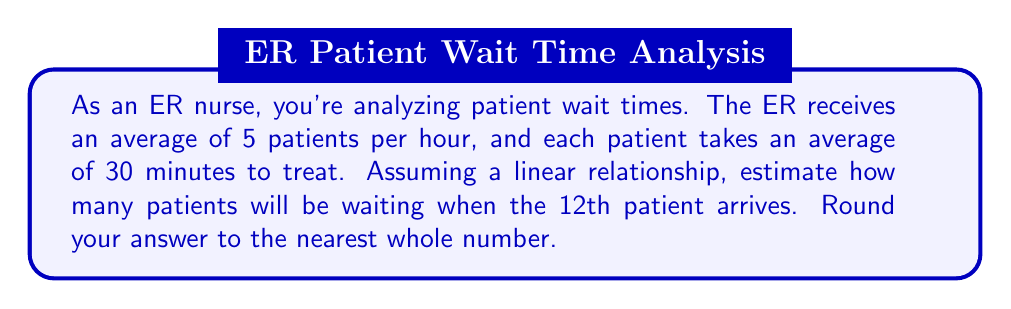Can you answer this question? Let's approach this step-by-step:

1) First, we need to determine how long it takes for the 12th patient to arrive:
   $$ \text{Time for 12th patient} = \frac{12 \text{ patients}}{5 \text{ patients/hour}} = 2.4 \text{ hours} $$

2) In 2.4 hours, the number of patients that can be treated is:
   $$ \text{Patients treated} = \frac{2.4 \text{ hours}}{0.5 \text{ hours/patient}} = 4.8 \text{ patients} $$

3) The number of waiting patients is the difference between arrivals and treatments:
   $$ \text{Waiting patients} = \text{Arrivals} - \text{Treated} $$
   $$ \text{Waiting patients} = 12 - 4.8 = 7.2 $$

4) Rounding to the nearest whole number:
   $$ \text{Waiting patients} \approx 7 $$

This linear model assumes constant arrival and treatment rates, which is a simplification of real ER dynamics. In practice, arrival rates and treatment times can vary widely based on factors such as time of day, day of week, and severity of cases.
Answer: 7 patients 